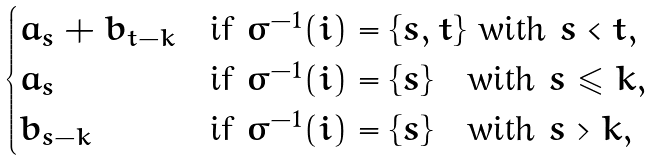<formula> <loc_0><loc_0><loc_500><loc_500>\begin{cases} a _ { s } + b _ { t - k } & \text {if } \sigma ^ { - 1 } ( i ) = \{ s , t \} \text { with } s < t , \\ a _ { s } & \text {if } \sigma ^ { - 1 } ( i ) = \{ s \} \quad \text {with } s \leqslant k , \\ b _ { s - k } & \text {if } \sigma ^ { - 1 } ( i ) = \{ s \} \quad \text {with } s > k , \\ \end{cases}</formula> 